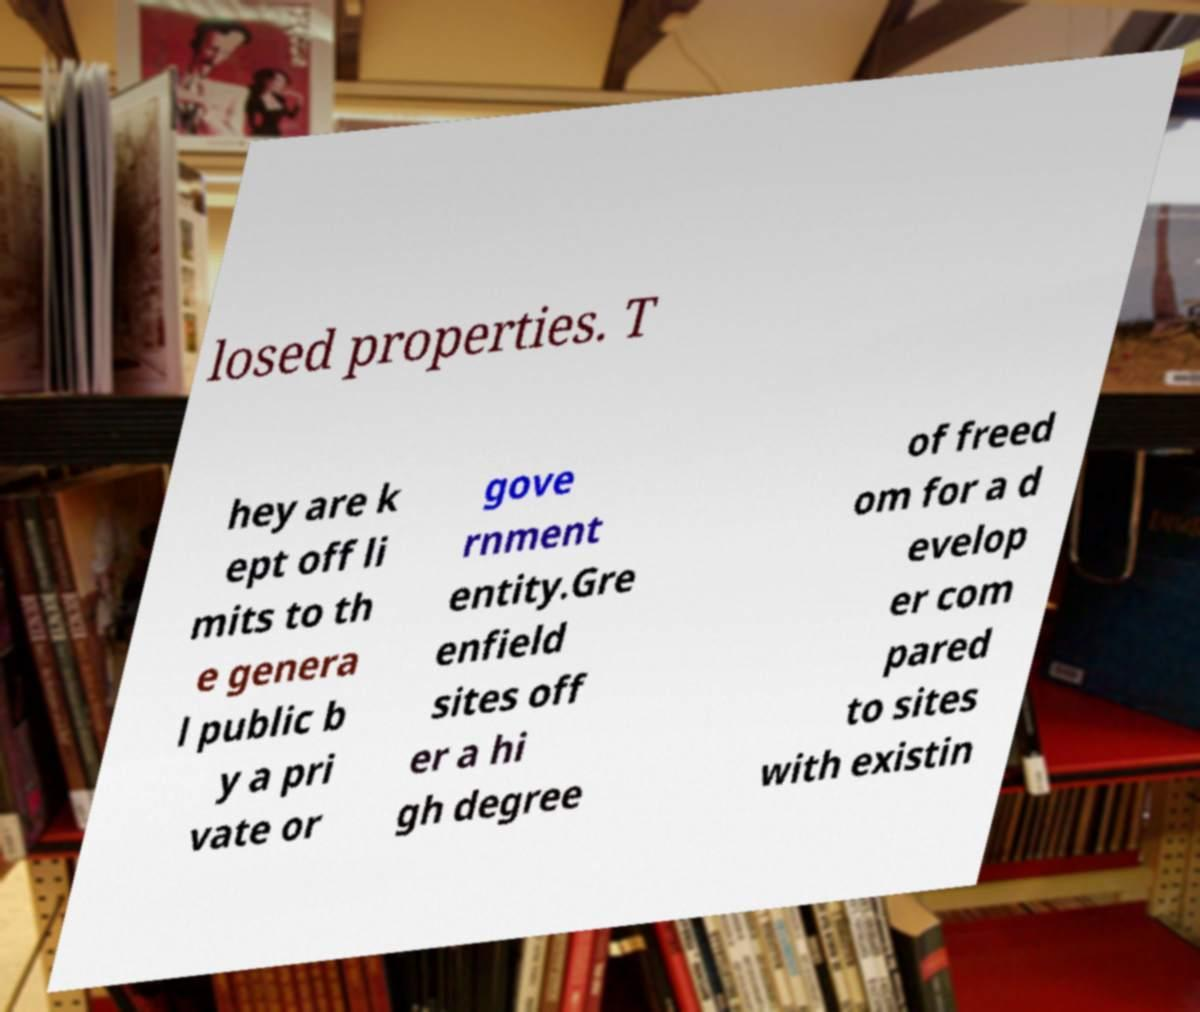I need the written content from this picture converted into text. Can you do that? losed properties. T hey are k ept off li mits to th e genera l public b y a pri vate or gove rnment entity.Gre enfield sites off er a hi gh degree of freed om for a d evelop er com pared to sites with existin 